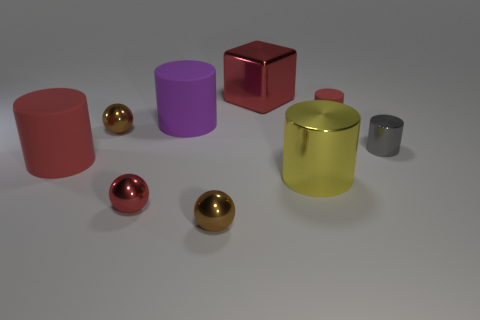How many large yellow cylinders are the same material as the small gray object?
Keep it short and to the point. 1. Do the tiny cylinder right of the tiny red rubber object and the purple cylinder behind the tiny shiny cylinder have the same material?
Your answer should be compact. No. What number of big metallic objects are in front of the red rubber thing that is on the right side of the small brown metal sphere behind the yellow cylinder?
Give a very brief answer. 1. There is a tiny object behind the purple cylinder; is it the same color as the big matte cylinder that is on the left side of the purple matte object?
Ensure brevity in your answer.  Yes. Is there anything else of the same color as the metallic block?
Ensure brevity in your answer.  Yes. There is a metallic cylinder on the right side of the matte thing behind the big purple matte cylinder; what color is it?
Provide a succinct answer. Gray. Are any tiny cyan metallic objects visible?
Ensure brevity in your answer.  No. The cylinder that is in front of the tiny metal cylinder and on the right side of the tiny red metal sphere is what color?
Offer a very short reply. Yellow. There is a red rubber cylinder to the right of the big yellow cylinder; is it the same size as the red matte thing that is in front of the purple object?
Make the answer very short. No. What number of other objects are the same size as the purple rubber cylinder?
Offer a very short reply. 3. 